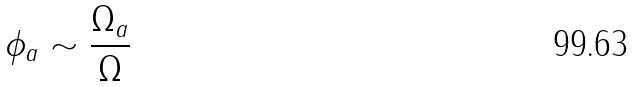<formula> <loc_0><loc_0><loc_500><loc_500>\phi _ { a } \sim \frac { \Omega _ { a } } { \Omega }</formula> 